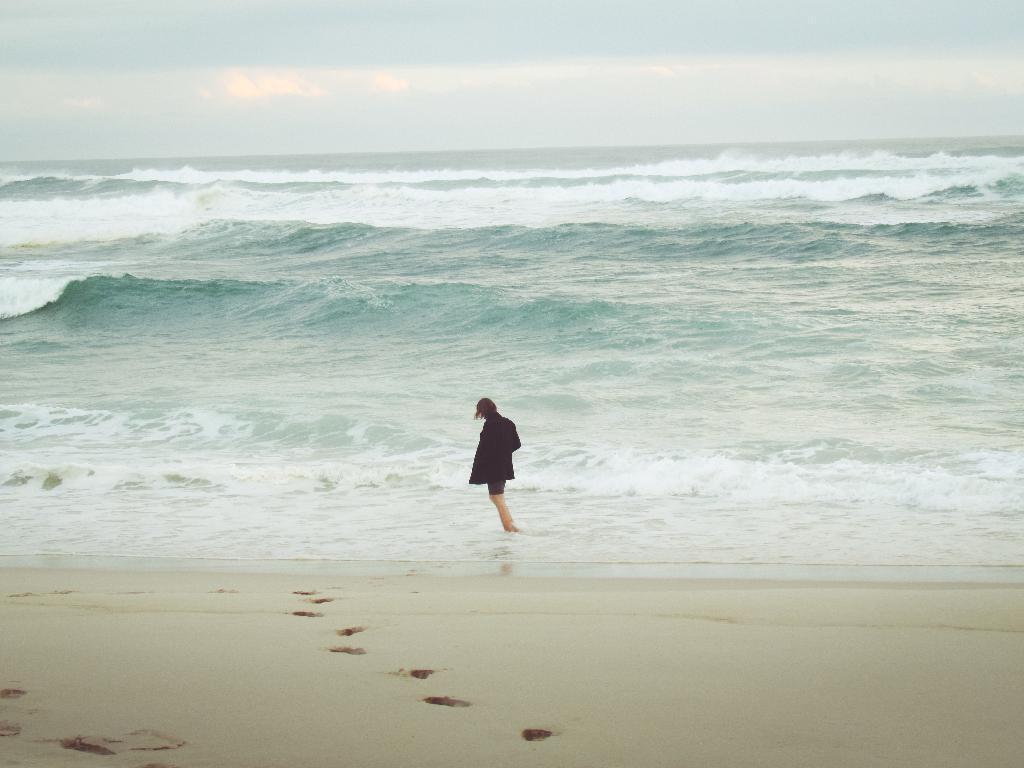How would you summarize this image in a sentence or two? In this picture I can observe a person standing in the water in the middle of the picture. In the background there is an ocean and I can observe sky. 